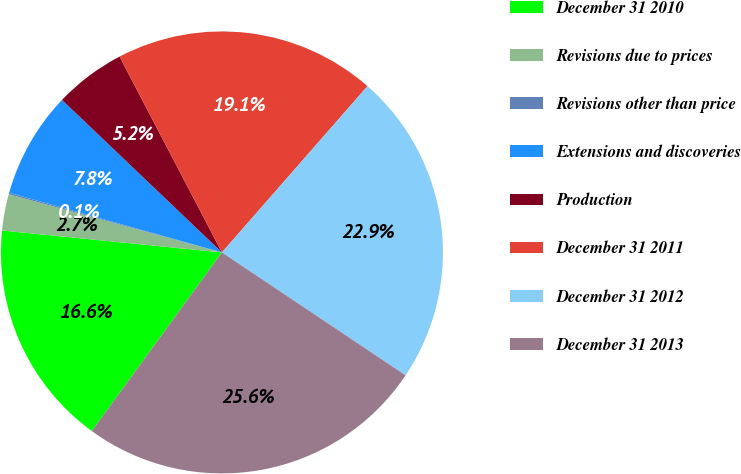<chart> <loc_0><loc_0><loc_500><loc_500><pie_chart><fcel>December 31 2010<fcel>Revisions due to prices<fcel>Revisions other than price<fcel>Extensions and discoveries<fcel>Production<fcel>December 31 2011<fcel>December 31 2012<fcel>December 31 2013<nl><fcel>16.56%<fcel>2.66%<fcel>0.11%<fcel>7.77%<fcel>5.21%<fcel>19.11%<fcel>22.94%<fcel>25.63%<nl></chart> 